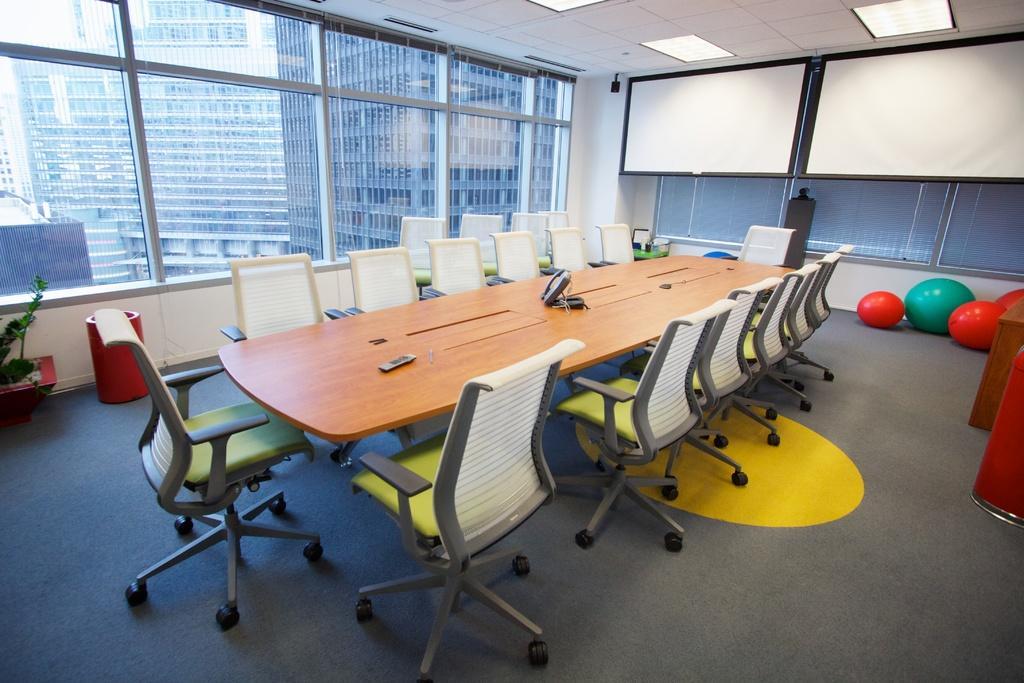Describe this image in one or two sentences. In the center of the image there is a table. On the table we can see telephone, remote are present, beside that chairs are there. In the background of the image we can see the window, boards are present. On the right side of the image exercise ball are there. At the bottom of the image floor is there. On the right side of the image plants is there. At the top of the image roof and lights are present. 